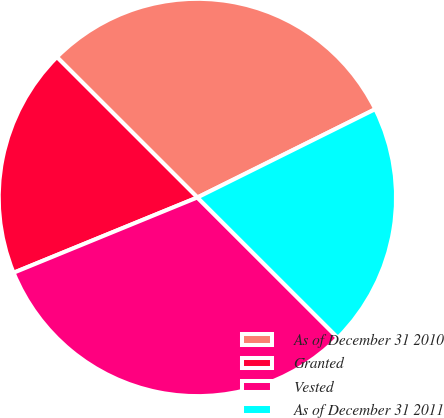<chart> <loc_0><loc_0><loc_500><loc_500><pie_chart><fcel>As of December 31 2010<fcel>Granted<fcel>Vested<fcel>As of December 31 2011<nl><fcel>30.17%<fcel>18.68%<fcel>31.32%<fcel>19.83%<nl></chart> 